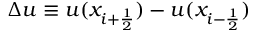Convert formula to latex. <formula><loc_0><loc_0><loc_500><loc_500>\Delta u \equiv u ( x _ { i + \frac { 1 } { 2 } } ) - u ( x _ { i - \frac { 1 } { 2 } } )</formula> 